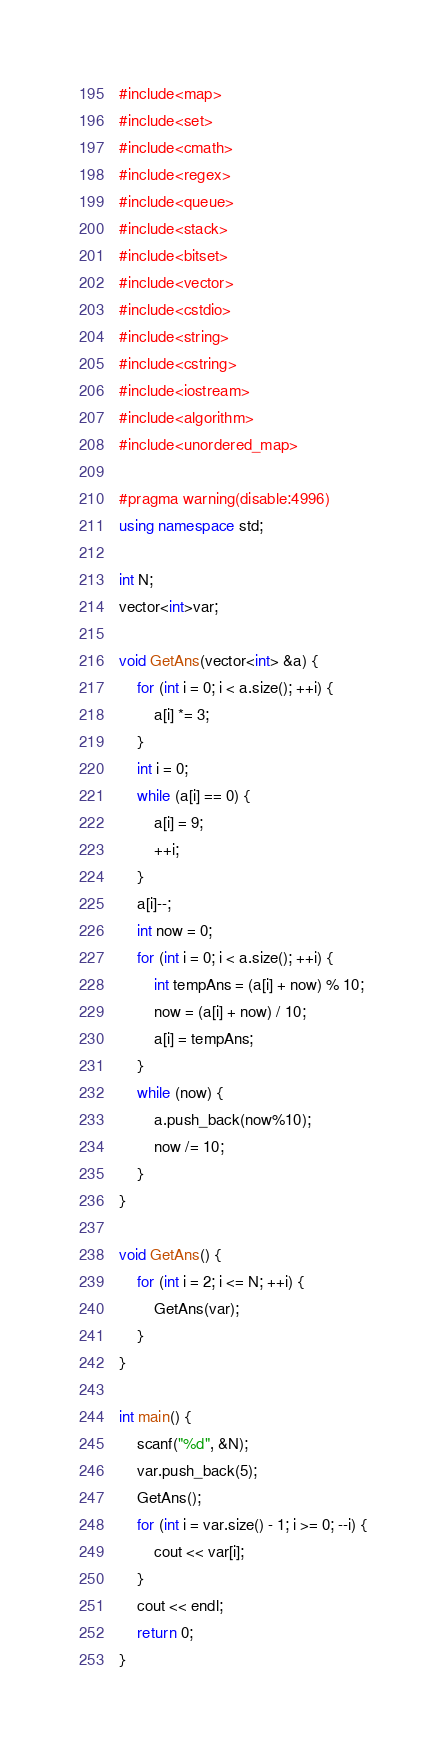Convert code to text. <code><loc_0><loc_0><loc_500><loc_500><_C++_>#include<map>
#include<set>
#include<cmath>
#include<regex>
#include<queue>
#include<stack>
#include<bitset>
#include<vector>
#include<cstdio>
#include<string>
#include<cstring>
#include<iostream>
#include<algorithm>
#include<unordered_map>

#pragma warning(disable:4996)
using namespace std;

int N;
vector<int>var;

void GetAns(vector<int> &a) {
	for (int i = 0; i < a.size(); ++i) {
		a[i] *= 3;
	}
	int i = 0;
	while (a[i] == 0) {
		a[i] = 9;
		++i;
	}
	a[i]--;
	int now = 0;
	for (int i = 0; i < a.size(); ++i) {
		int tempAns = (a[i] + now) % 10;
		now = (a[i] + now) / 10;
		a[i] = tempAns;
	}
	while (now) {
		a.push_back(now%10);
		now /= 10;
	}
}

void GetAns() {
	for (int i = 2; i <= N; ++i) {
		GetAns(var);
	}
}

int main() {
	scanf("%d", &N);
	var.push_back(5);
	GetAns();
	for (int i = var.size() - 1; i >= 0; --i) {
		cout << var[i];
	}
	cout << endl;
	return 0;
}</code> 